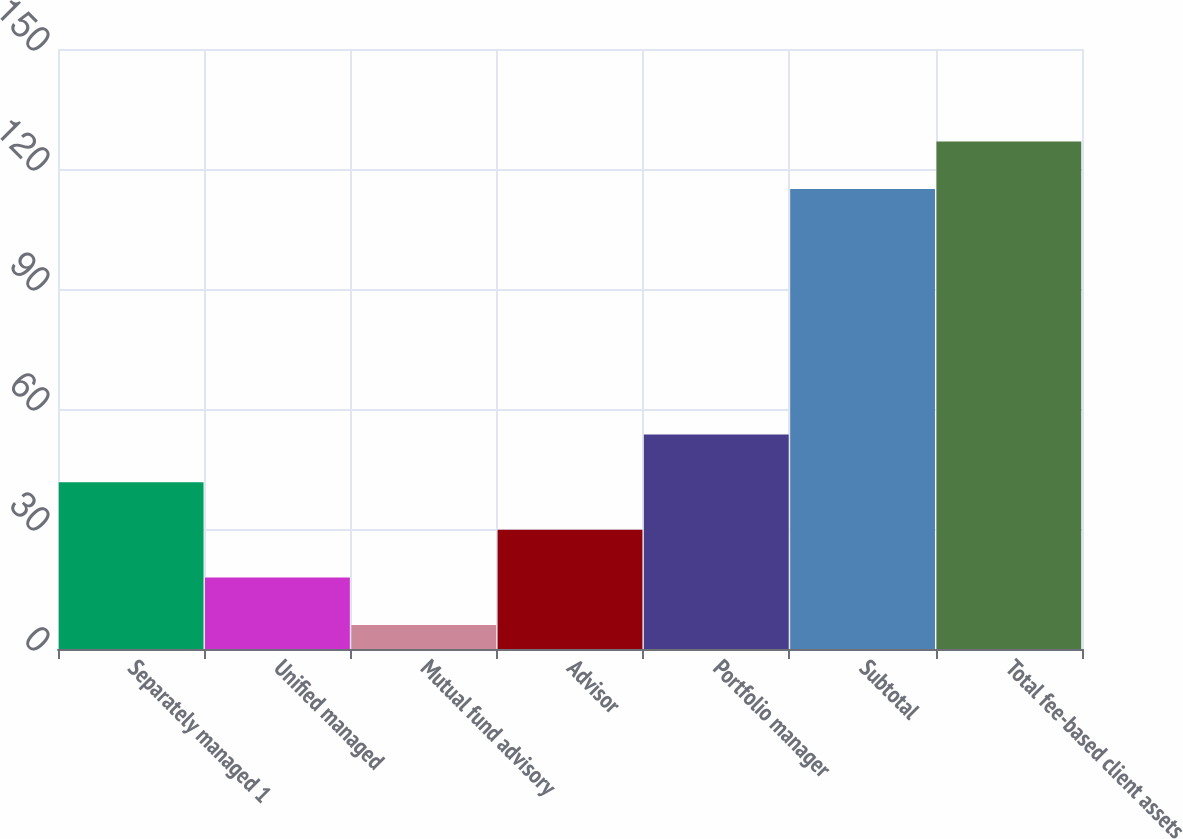<chart> <loc_0><loc_0><loc_500><loc_500><bar_chart><fcel>Separately managed 1<fcel>Unified managed<fcel>Mutual fund advisory<fcel>Advisor<fcel>Portfolio manager<fcel>Subtotal<fcel>Total fee-based client assets<nl><fcel>41.7<fcel>17.9<fcel>6<fcel>29.8<fcel>53.6<fcel>115<fcel>126.9<nl></chart> 